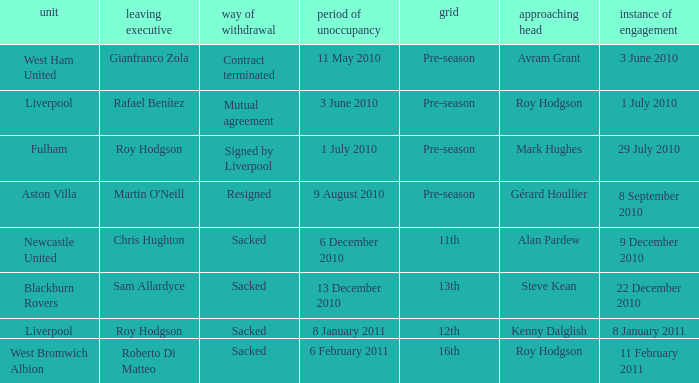What was the date of appointment for incoming manager Roy Hodgson and the team is Liverpool? 1 July 2010. 